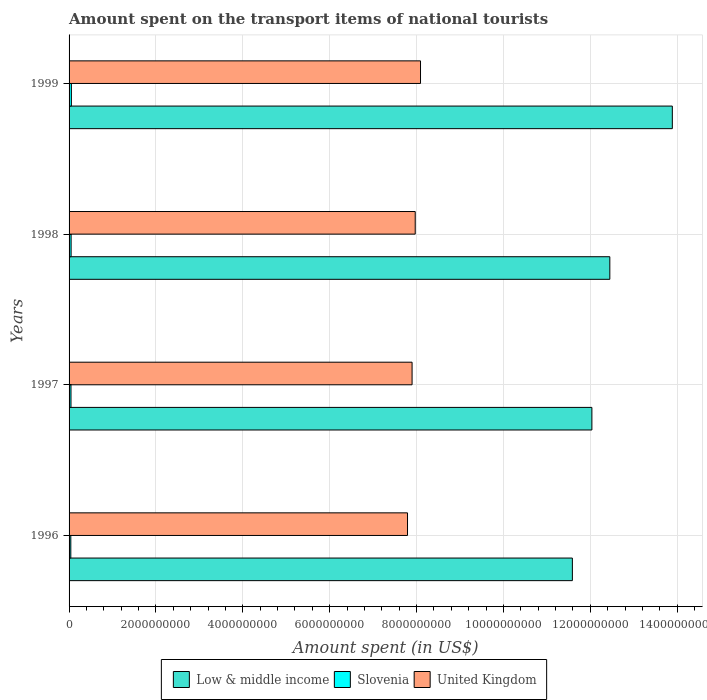How many bars are there on the 1st tick from the top?
Ensure brevity in your answer.  3. How many bars are there on the 1st tick from the bottom?
Offer a terse response. 3. What is the label of the 3rd group of bars from the top?
Offer a very short reply. 1997. What is the amount spent on the transport items of national tourists in Slovenia in 1999?
Your answer should be very brief. 5.30e+07. Across all years, what is the maximum amount spent on the transport items of national tourists in United Kingdom?
Make the answer very short. 8.09e+09. Across all years, what is the minimum amount spent on the transport items of national tourists in Slovenia?
Make the answer very short. 4.00e+07. In which year was the amount spent on the transport items of national tourists in Slovenia maximum?
Your response must be concise. 1999. What is the total amount spent on the transport items of national tourists in Slovenia in the graph?
Offer a very short reply. 1.84e+08. What is the difference between the amount spent on the transport items of national tourists in Slovenia in 1998 and that in 1999?
Offer a very short reply. -6.00e+06. What is the difference between the amount spent on the transport items of national tourists in United Kingdom in 1996 and the amount spent on the transport items of national tourists in Low & middle income in 1998?
Make the answer very short. -4.66e+09. What is the average amount spent on the transport items of national tourists in Low & middle income per year?
Ensure brevity in your answer.  1.25e+1. In the year 1999, what is the difference between the amount spent on the transport items of national tourists in Slovenia and amount spent on the transport items of national tourists in Low & middle income?
Your answer should be very brief. -1.38e+1. What is the ratio of the amount spent on the transport items of national tourists in Slovenia in 1997 to that in 1999?
Provide a short and direct response. 0.83. What is the difference between the highest and the second highest amount spent on the transport items of national tourists in Low & middle income?
Make the answer very short. 1.44e+09. What is the difference between the highest and the lowest amount spent on the transport items of national tourists in Slovenia?
Provide a short and direct response. 1.30e+07. In how many years, is the amount spent on the transport items of national tourists in Low & middle income greater than the average amount spent on the transport items of national tourists in Low & middle income taken over all years?
Your response must be concise. 1. Are all the bars in the graph horizontal?
Offer a very short reply. Yes. How many years are there in the graph?
Give a very brief answer. 4. Does the graph contain any zero values?
Offer a terse response. No. How many legend labels are there?
Your answer should be very brief. 3. How are the legend labels stacked?
Your answer should be compact. Horizontal. What is the title of the graph?
Provide a succinct answer. Amount spent on the transport items of national tourists. What is the label or title of the X-axis?
Offer a very short reply. Amount spent (in US$). What is the Amount spent (in US$) in Low & middle income in 1996?
Make the answer very short. 1.16e+1. What is the Amount spent (in US$) in Slovenia in 1996?
Give a very brief answer. 4.00e+07. What is the Amount spent (in US$) in United Kingdom in 1996?
Provide a succinct answer. 7.79e+09. What is the Amount spent (in US$) in Low & middle income in 1997?
Offer a very short reply. 1.20e+1. What is the Amount spent (in US$) of Slovenia in 1997?
Your response must be concise. 4.40e+07. What is the Amount spent (in US$) of United Kingdom in 1997?
Ensure brevity in your answer.  7.90e+09. What is the Amount spent (in US$) of Low & middle income in 1998?
Your response must be concise. 1.24e+1. What is the Amount spent (in US$) of Slovenia in 1998?
Your response must be concise. 4.70e+07. What is the Amount spent (in US$) of United Kingdom in 1998?
Provide a short and direct response. 7.97e+09. What is the Amount spent (in US$) in Low & middle income in 1999?
Keep it short and to the point. 1.39e+1. What is the Amount spent (in US$) in Slovenia in 1999?
Your response must be concise. 5.30e+07. What is the Amount spent (in US$) of United Kingdom in 1999?
Keep it short and to the point. 8.09e+09. Across all years, what is the maximum Amount spent (in US$) in Low & middle income?
Offer a very short reply. 1.39e+1. Across all years, what is the maximum Amount spent (in US$) in Slovenia?
Offer a very short reply. 5.30e+07. Across all years, what is the maximum Amount spent (in US$) in United Kingdom?
Your answer should be very brief. 8.09e+09. Across all years, what is the minimum Amount spent (in US$) of Low & middle income?
Your answer should be compact. 1.16e+1. Across all years, what is the minimum Amount spent (in US$) in Slovenia?
Provide a short and direct response. 4.00e+07. Across all years, what is the minimum Amount spent (in US$) of United Kingdom?
Offer a very short reply. 7.79e+09. What is the total Amount spent (in US$) of Low & middle income in the graph?
Your answer should be compact. 5.00e+1. What is the total Amount spent (in US$) of Slovenia in the graph?
Make the answer very short. 1.84e+08. What is the total Amount spent (in US$) in United Kingdom in the graph?
Your answer should be compact. 3.17e+1. What is the difference between the Amount spent (in US$) in Low & middle income in 1996 and that in 1997?
Make the answer very short. -4.49e+08. What is the difference between the Amount spent (in US$) in Slovenia in 1996 and that in 1997?
Ensure brevity in your answer.  -4.00e+06. What is the difference between the Amount spent (in US$) of United Kingdom in 1996 and that in 1997?
Make the answer very short. -1.05e+08. What is the difference between the Amount spent (in US$) in Low & middle income in 1996 and that in 1998?
Give a very brief answer. -8.62e+08. What is the difference between the Amount spent (in US$) in Slovenia in 1996 and that in 1998?
Provide a short and direct response. -7.00e+06. What is the difference between the Amount spent (in US$) in United Kingdom in 1996 and that in 1998?
Your answer should be compact. -1.77e+08. What is the difference between the Amount spent (in US$) of Low & middle income in 1996 and that in 1999?
Your answer should be compact. -2.30e+09. What is the difference between the Amount spent (in US$) of Slovenia in 1996 and that in 1999?
Keep it short and to the point. -1.30e+07. What is the difference between the Amount spent (in US$) in United Kingdom in 1996 and that in 1999?
Give a very brief answer. -2.99e+08. What is the difference between the Amount spent (in US$) of Low & middle income in 1997 and that in 1998?
Ensure brevity in your answer.  -4.13e+08. What is the difference between the Amount spent (in US$) in Slovenia in 1997 and that in 1998?
Offer a terse response. -3.00e+06. What is the difference between the Amount spent (in US$) in United Kingdom in 1997 and that in 1998?
Make the answer very short. -7.20e+07. What is the difference between the Amount spent (in US$) of Low & middle income in 1997 and that in 1999?
Your answer should be very brief. -1.85e+09. What is the difference between the Amount spent (in US$) in Slovenia in 1997 and that in 1999?
Your answer should be very brief. -9.00e+06. What is the difference between the Amount spent (in US$) of United Kingdom in 1997 and that in 1999?
Your answer should be very brief. -1.94e+08. What is the difference between the Amount spent (in US$) in Low & middle income in 1998 and that in 1999?
Keep it short and to the point. -1.44e+09. What is the difference between the Amount spent (in US$) of Slovenia in 1998 and that in 1999?
Offer a very short reply. -6.00e+06. What is the difference between the Amount spent (in US$) in United Kingdom in 1998 and that in 1999?
Your answer should be very brief. -1.22e+08. What is the difference between the Amount spent (in US$) of Low & middle income in 1996 and the Amount spent (in US$) of Slovenia in 1997?
Provide a succinct answer. 1.15e+1. What is the difference between the Amount spent (in US$) in Low & middle income in 1996 and the Amount spent (in US$) in United Kingdom in 1997?
Ensure brevity in your answer.  3.69e+09. What is the difference between the Amount spent (in US$) of Slovenia in 1996 and the Amount spent (in US$) of United Kingdom in 1997?
Ensure brevity in your answer.  -7.86e+09. What is the difference between the Amount spent (in US$) of Low & middle income in 1996 and the Amount spent (in US$) of Slovenia in 1998?
Provide a short and direct response. 1.15e+1. What is the difference between the Amount spent (in US$) in Low & middle income in 1996 and the Amount spent (in US$) in United Kingdom in 1998?
Ensure brevity in your answer.  3.62e+09. What is the difference between the Amount spent (in US$) of Slovenia in 1996 and the Amount spent (in US$) of United Kingdom in 1998?
Provide a succinct answer. -7.93e+09. What is the difference between the Amount spent (in US$) in Low & middle income in 1996 and the Amount spent (in US$) in Slovenia in 1999?
Offer a very short reply. 1.15e+1. What is the difference between the Amount spent (in US$) of Low & middle income in 1996 and the Amount spent (in US$) of United Kingdom in 1999?
Your response must be concise. 3.50e+09. What is the difference between the Amount spent (in US$) of Slovenia in 1996 and the Amount spent (in US$) of United Kingdom in 1999?
Make the answer very short. -8.05e+09. What is the difference between the Amount spent (in US$) of Low & middle income in 1997 and the Amount spent (in US$) of Slovenia in 1998?
Make the answer very short. 1.20e+1. What is the difference between the Amount spent (in US$) of Low & middle income in 1997 and the Amount spent (in US$) of United Kingdom in 1998?
Your response must be concise. 4.07e+09. What is the difference between the Amount spent (in US$) of Slovenia in 1997 and the Amount spent (in US$) of United Kingdom in 1998?
Give a very brief answer. -7.92e+09. What is the difference between the Amount spent (in US$) of Low & middle income in 1997 and the Amount spent (in US$) of Slovenia in 1999?
Give a very brief answer. 1.20e+1. What is the difference between the Amount spent (in US$) of Low & middle income in 1997 and the Amount spent (in US$) of United Kingdom in 1999?
Offer a very short reply. 3.95e+09. What is the difference between the Amount spent (in US$) in Slovenia in 1997 and the Amount spent (in US$) in United Kingdom in 1999?
Make the answer very short. -8.05e+09. What is the difference between the Amount spent (in US$) of Low & middle income in 1998 and the Amount spent (in US$) of Slovenia in 1999?
Keep it short and to the point. 1.24e+1. What is the difference between the Amount spent (in US$) in Low & middle income in 1998 and the Amount spent (in US$) in United Kingdom in 1999?
Your answer should be very brief. 4.36e+09. What is the difference between the Amount spent (in US$) in Slovenia in 1998 and the Amount spent (in US$) in United Kingdom in 1999?
Provide a succinct answer. -8.04e+09. What is the average Amount spent (in US$) in Low & middle income per year?
Your answer should be compact. 1.25e+1. What is the average Amount spent (in US$) in Slovenia per year?
Keep it short and to the point. 4.60e+07. What is the average Amount spent (in US$) in United Kingdom per year?
Your answer should be very brief. 7.94e+09. In the year 1996, what is the difference between the Amount spent (in US$) in Low & middle income and Amount spent (in US$) in Slovenia?
Provide a succinct answer. 1.15e+1. In the year 1996, what is the difference between the Amount spent (in US$) in Low & middle income and Amount spent (in US$) in United Kingdom?
Make the answer very short. 3.80e+09. In the year 1996, what is the difference between the Amount spent (in US$) of Slovenia and Amount spent (in US$) of United Kingdom?
Make the answer very short. -7.75e+09. In the year 1997, what is the difference between the Amount spent (in US$) of Low & middle income and Amount spent (in US$) of Slovenia?
Provide a short and direct response. 1.20e+1. In the year 1997, what is the difference between the Amount spent (in US$) in Low & middle income and Amount spent (in US$) in United Kingdom?
Your response must be concise. 4.14e+09. In the year 1997, what is the difference between the Amount spent (in US$) of Slovenia and Amount spent (in US$) of United Kingdom?
Give a very brief answer. -7.85e+09. In the year 1998, what is the difference between the Amount spent (in US$) of Low & middle income and Amount spent (in US$) of Slovenia?
Your answer should be compact. 1.24e+1. In the year 1998, what is the difference between the Amount spent (in US$) in Low & middle income and Amount spent (in US$) in United Kingdom?
Give a very brief answer. 4.48e+09. In the year 1998, what is the difference between the Amount spent (in US$) in Slovenia and Amount spent (in US$) in United Kingdom?
Your answer should be compact. -7.92e+09. In the year 1999, what is the difference between the Amount spent (in US$) in Low & middle income and Amount spent (in US$) in Slovenia?
Your response must be concise. 1.38e+1. In the year 1999, what is the difference between the Amount spent (in US$) in Low & middle income and Amount spent (in US$) in United Kingdom?
Ensure brevity in your answer.  5.80e+09. In the year 1999, what is the difference between the Amount spent (in US$) of Slovenia and Amount spent (in US$) of United Kingdom?
Keep it short and to the point. -8.04e+09. What is the ratio of the Amount spent (in US$) of Low & middle income in 1996 to that in 1997?
Provide a succinct answer. 0.96. What is the ratio of the Amount spent (in US$) of United Kingdom in 1996 to that in 1997?
Offer a terse response. 0.99. What is the ratio of the Amount spent (in US$) in Low & middle income in 1996 to that in 1998?
Provide a succinct answer. 0.93. What is the ratio of the Amount spent (in US$) in Slovenia in 1996 to that in 1998?
Give a very brief answer. 0.85. What is the ratio of the Amount spent (in US$) of United Kingdom in 1996 to that in 1998?
Your answer should be very brief. 0.98. What is the ratio of the Amount spent (in US$) in Low & middle income in 1996 to that in 1999?
Your answer should be very brief. 0.83. What is the ratio of the Amount spent (in US$) in Slovenia in 1996 to that in 1999?
Keep it short and to the point. 0.75. What is the ratio of the Amount spent (in US$) of Low & middle income in 1997 to that in 1998?
Your response must be concise. 0.97. What is the ratio of the Amount spent (in US$) in Slovenia in 1997 to that in 1998?
Your answer should be very brief. 0.94. What is the ratio of the Amount spent (in US$) of United Kingdom in 1997 to that in 1998?
Ensure brevity in your answer.  0.99. What is the ratio of the Amount spent (in US$) of Low & middle income in 1997 to that in 1999?
Your answer should be very brief. 0.87. What is the ratio of the Amount spent (in US$) in Slovenia in 1997 to that in 1999?
Ensure brevity in your answer.  0.83. What is the ratio of the Amount spent (in US$) in United Kingdom in 1997 to that in 1999?
Your answer should be compact. 0.98. What is the ratio of the Amount spent (in US$) of Low & middle income in 1998 to that in 1999?
Provide a succinct answer. 0.9. What is the ratio of the Amount spent (in US$) in Slovenia in 1998 to that in 1999?
Offer a terse response. 0.89. What is the ratio of the Amount spent (in US$) in United Kingdom in 1998 to that in 1999?
Ensure brevity in your answer.  0.98. What is the difference between the highest and the second highest Amount spent (in US$) in Low & middle income?
Offer a very short reply. 1.44e+09. What is the difference between the highest and the second highest Amount spent (in US$) in Slovenia?
Your response must be concise. 6.00e+06. What is the difference between the highest and the second highest Amount spent (in US$) in United Kingdom?
Your answer should be very brief. 1.22e+08. What is the difference between the highest and the lowest Amount spent (in US$) in Low & middle income?
Give a very brief answer. 2.30e+09. What is the difference between the highest and the lowest Amount spent (in US$) of Slovenia?
Offer a very short reply. 1.30e+07. What is the difference between the highest and the lowest Amount spent (in US$) of United Kingdom?
Your answer should be compact. 2.99e+08. 